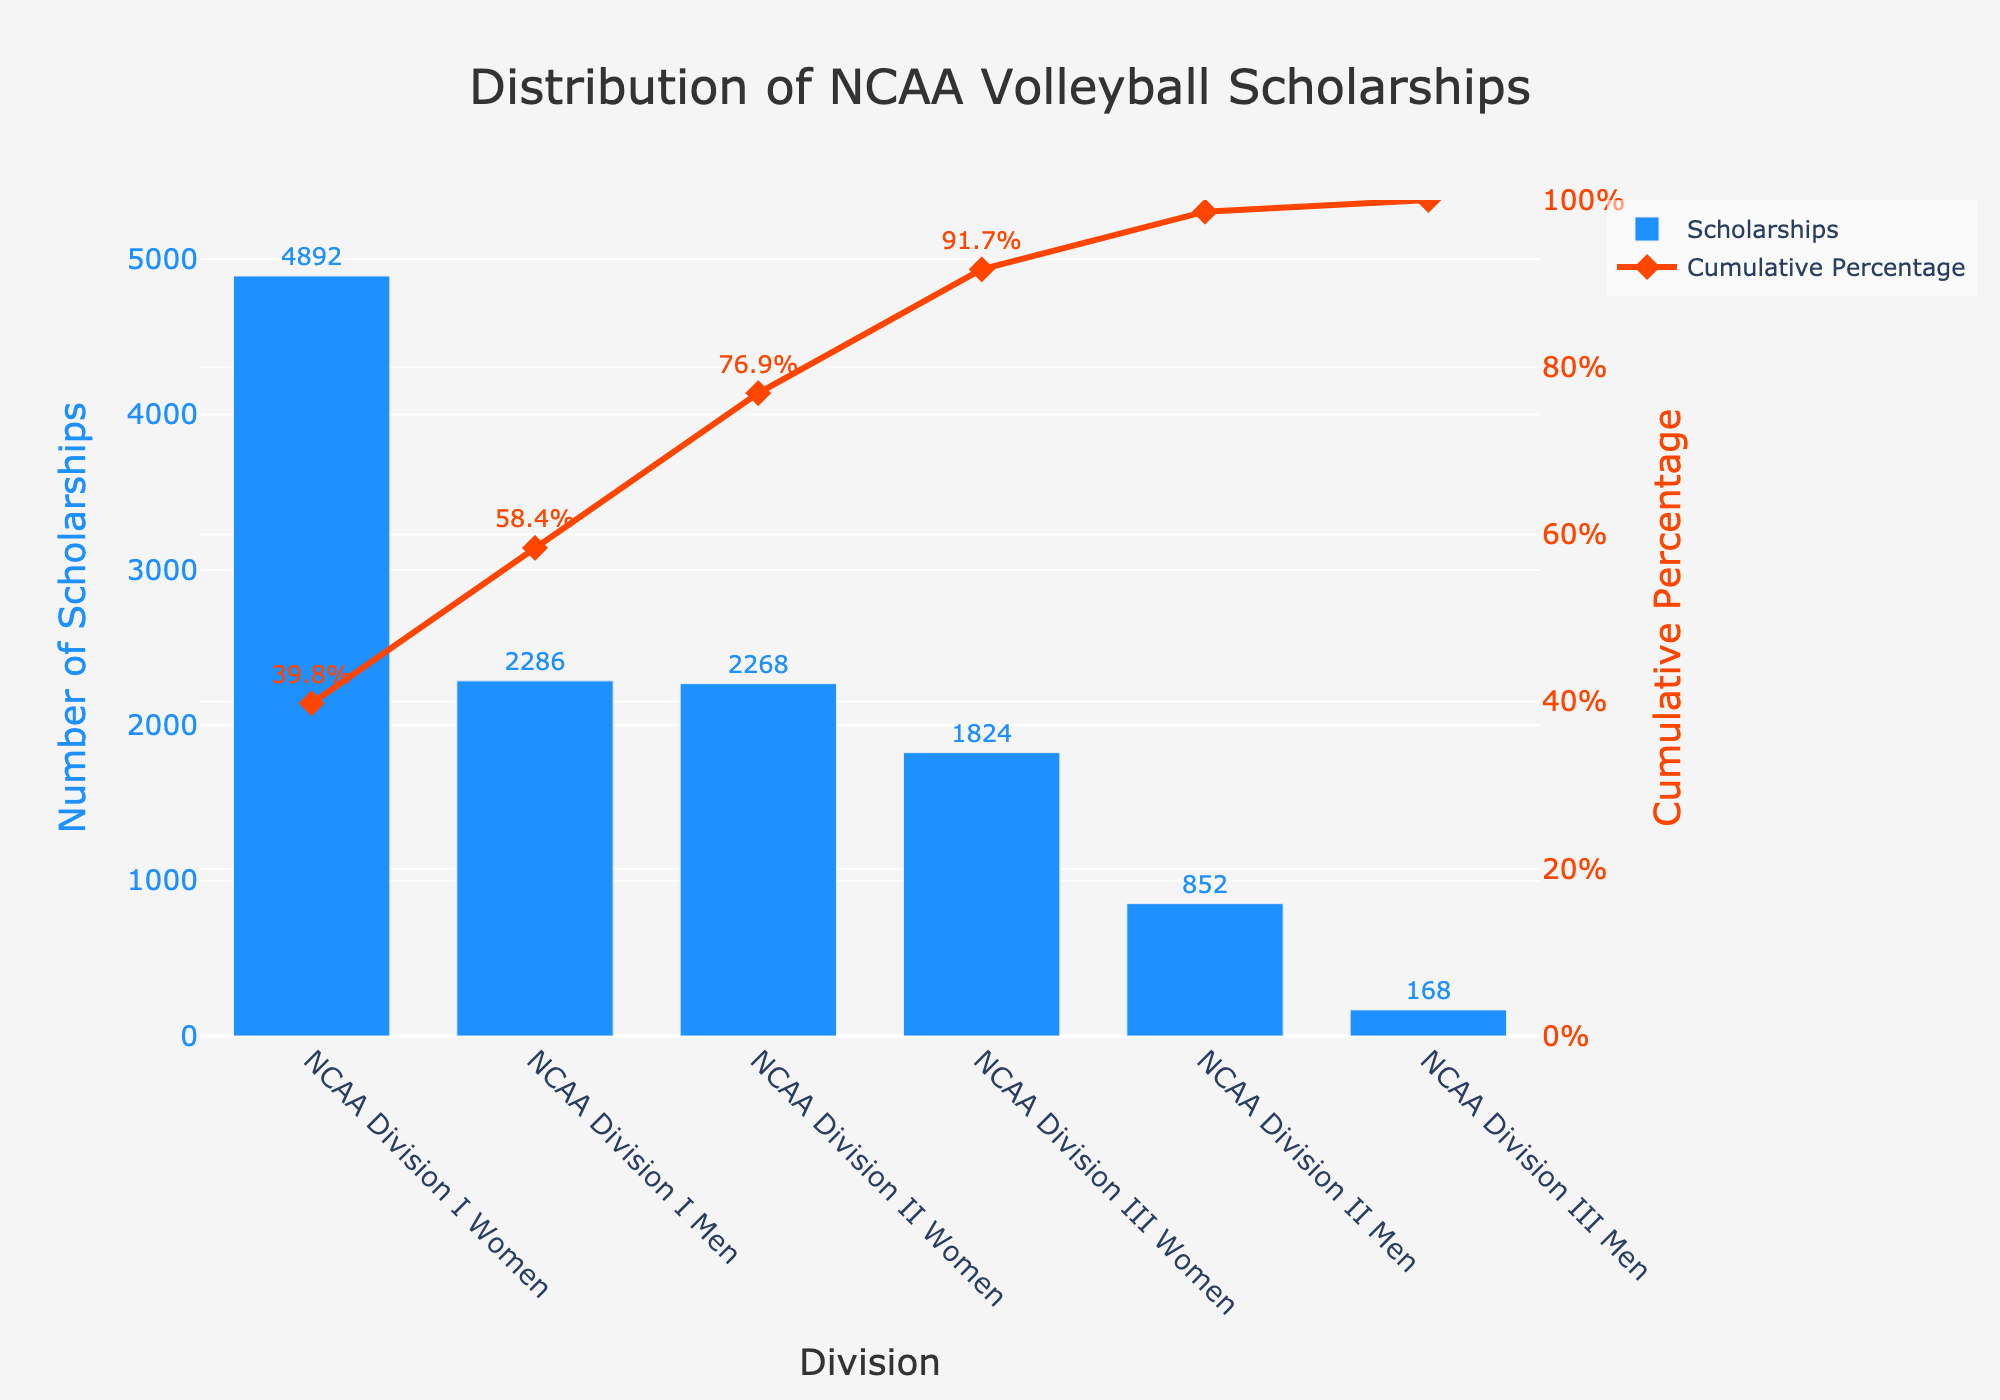What is the title of the figure? The title is usually displayed prominently at the top of the chart. Here, "Distribution of NCAA Volleyball Scholarships" is the only text that fits the format of a title, based on normal chart conventions.
Answer: Distribution of NCAA Volleyball Scholarships What does the x-axis represent in this figure? The x-axis typically displays the categories being analyzed. In this case, it displays the NCAA divisions combined with the gender for different scholarships.
Answer: Division Which division has the highest number of scholarships? By looking at the bar heights, the NCAA Division I Women category has the tallest bar, indicating the highest number of scholarships.
Answer: NCAA Division I Women What is the cumulative percentage of scholarships after the NCAA Division II Women category? By inspecting the line that represents the cumulative percentage, at the point of NCAA Division II Women, the cumulative percentage is 76.9%.
Answer: 76.9% How many scholarships are provided by NCAA Division III Men? The bar corresponding to NCAA Division III Men has the value of 168 scholarships written on it.
Answer: 168 Which division and gender have a cumulative percentage closest to but less than 60%? Looking at the markers on the cumulative percentage line, we see that NCAA Division I Men has a cumulative percentage of 58.4%, which is closest to but less than 60%.
Answer: NCAA Division I Men What is the total number of scholarships provided by NCAA Division I for both genders? Summing the number for NCAA Division I Women (4892) and NCAA Division I Men (2286) gives the total scholarships for Division I.
Answer: 4892 + 2286 = 7178 Which category contributes the least number of scholarships, and how does it affect the cumulative percentage? The bar for NCAA Division III Men is the shortest with 168 scholarships, and the cumulative percentage reaches 100% after including this category.
Answer: NCAA Division III Men, reaches 100% If you were to add the scholarships from NCAA Division III Women and NCAA Division II Men, what would be the result? Summing the scholarships for NCAA Division III Women (1824) and NCAA Division II Men (852) gives the result.
Answer: 1824 + 852 = 2676 What is the cumulative percentage of scholarships after NCAA Division I Men? The cumulative percentage after NCAA Division I Men is displayed as 58.4%.
Answer: 58.4% 